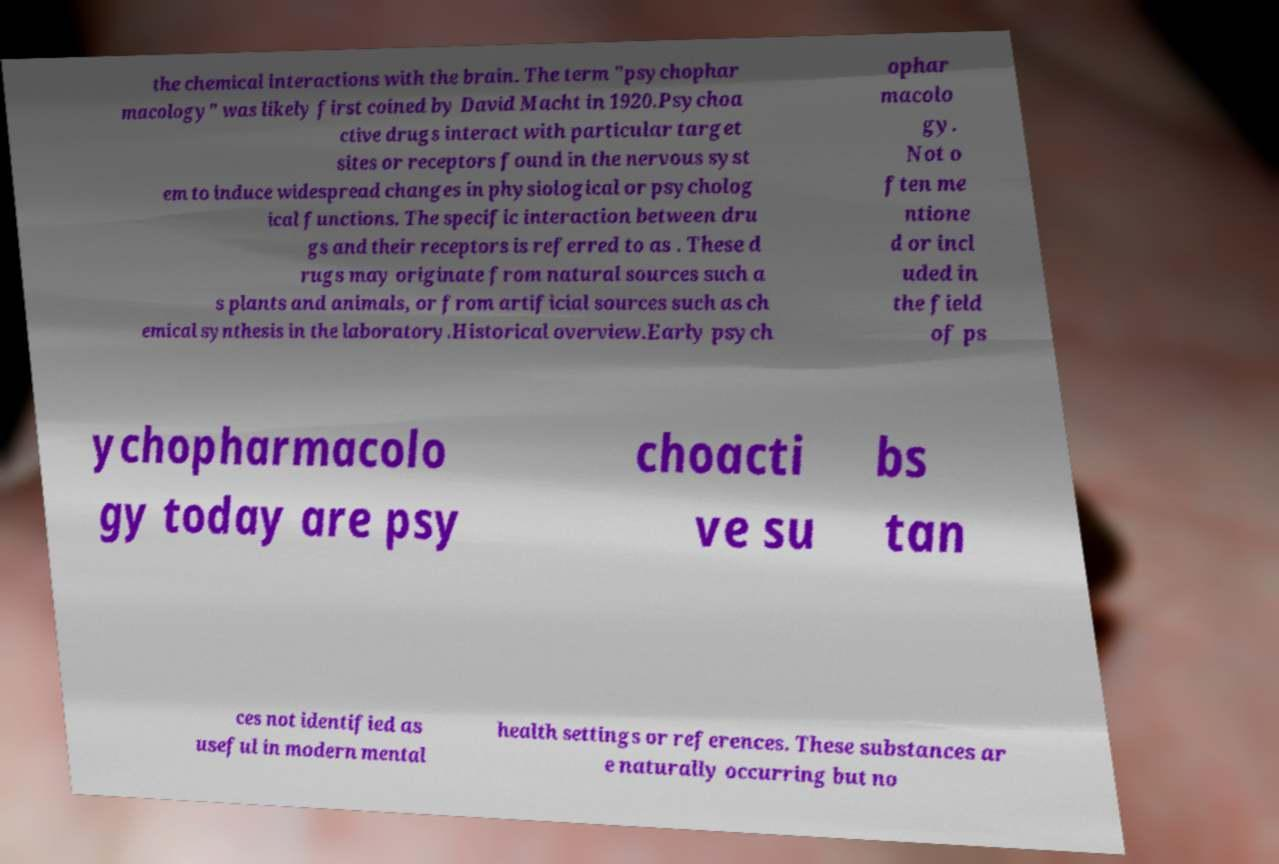What messages or text are displayed in this image? I need them in a readable, typed format. the chemical interactions with the brain. The term "psychophar macology" was likely first coined by David Macht in 1920.Psychoa ctive drugs interact with particular target sites or receptors found in the nervous syst em to induce widespread changes in physiological or psycholog ical functions. The specific interaction between dru gs and their receptors is referred to as . These d rugs may originate from natural sources such a s plants and animals, or from artificial sources such as ch emical synthesis in the laboratory.Historical overview.Early psych ophar macolo gy. Not o ften me ntione d or incl uded in the field of ps ychopharmacolo gy today are psy choacti ve su bs tan ces not identified as useful in modern mental health settings or references. These substances ar e naturally occurring but no 